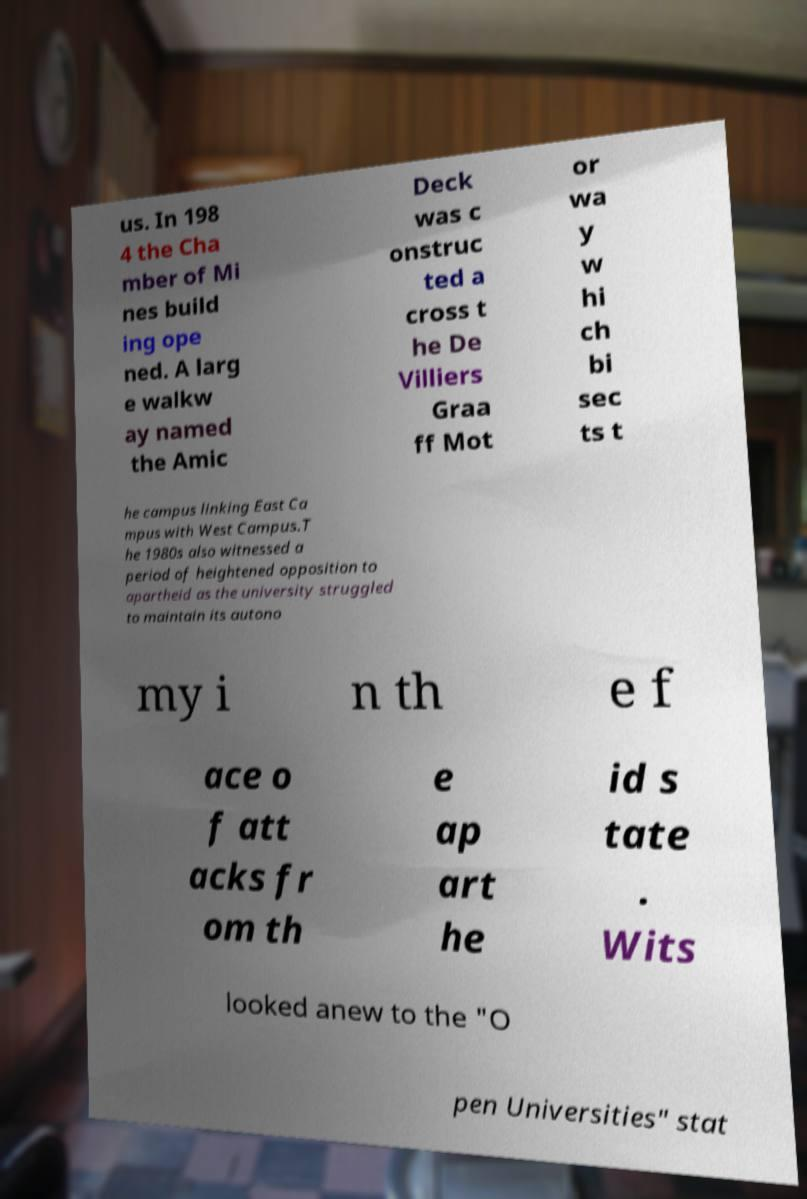Can you read and provide the text displayed in the image?This photo seems to have some interesting text. Can you extract and type it out for me? us. In 198 4 the Cha mber of Mi nes build ing ope ned. A larg e walkw ay named the Amic Deck was c onstruc ted a cross t he De Villiers Graa ff Mot or wa y w hi ch bi sec ts t he campus linking East Ca mpus with West Campus.T he 1980s also witnessed a period of heightened opposition to apartheid as the university struggled to maintain its autono my i n th e f ace o f att acks fr om th e ap art he id s tate . Wits looked anew to the "O pen Universities" stat 